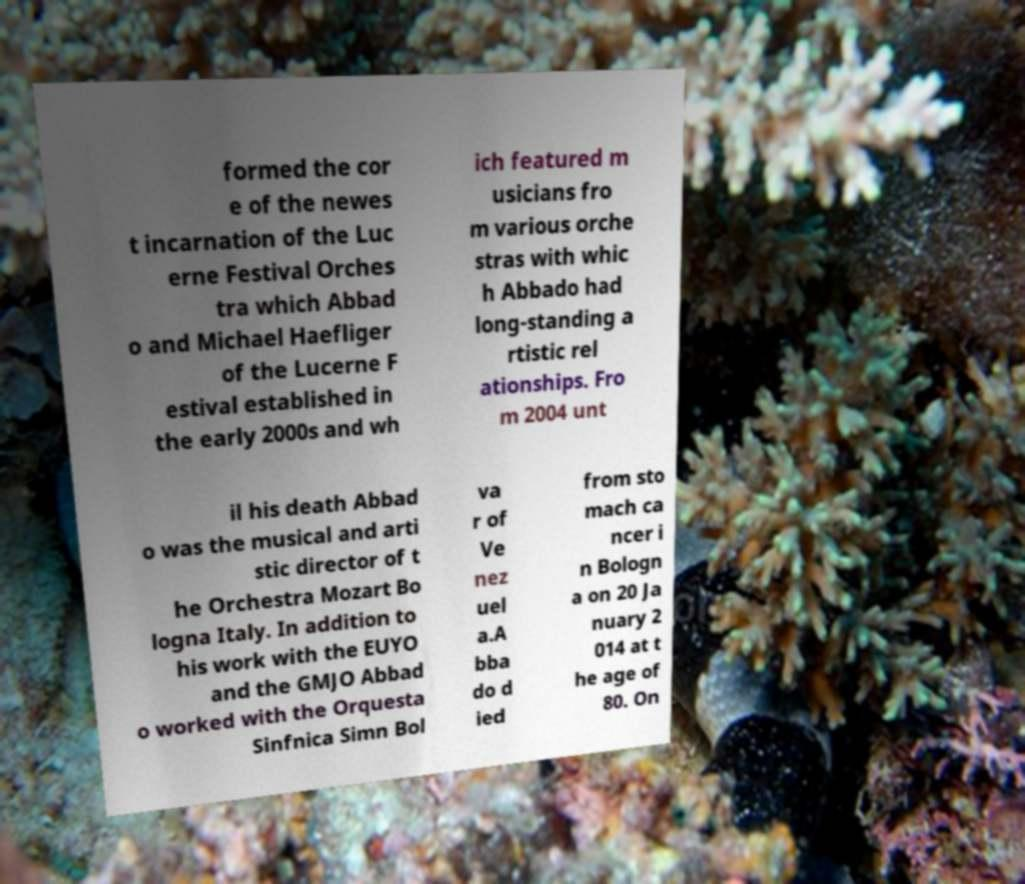Please read and relay the text visible in this image. What does it say? formed the cor e of the newes t incarnation of the Luc erne Festival Orches tra which Abbad o and Michael Haefliger of the Lucerne F estival established in the early 2000s and wh ich featured m usicians fro m various orche stras with whic h Abbado had long-standing a rtistic rel ationships. Fro m 2004 unt il his death Abbad o was the musical and arti stic director of t he Orchestra Mozart Bo logna Italy. In addition to his work with the EUYO and the GMJO Abbad o worked with the Orquesta Sinfnica Simn Bol va r of Ve nez uel a.A bba do d ied from sto mach ca ncer i n Bologn a on 20 Ja nuary 2 014 at t he age of 80. On 